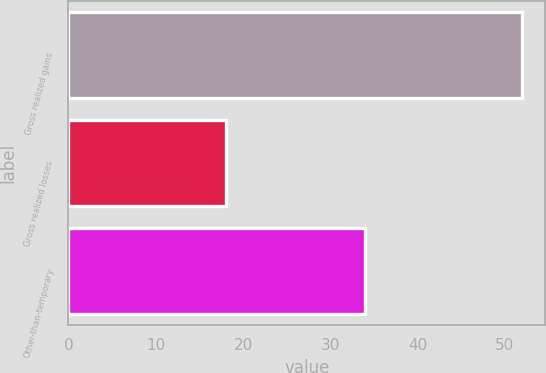<chart> <loc_0><loc_0><loc_500><loc_500><bar_chart><fcel>Gross realized gains<fcel>Gross realized losses<fcel>Other-than-temporary<nl><fcel>52<fcel>18<fcel>34<nl></chart> 